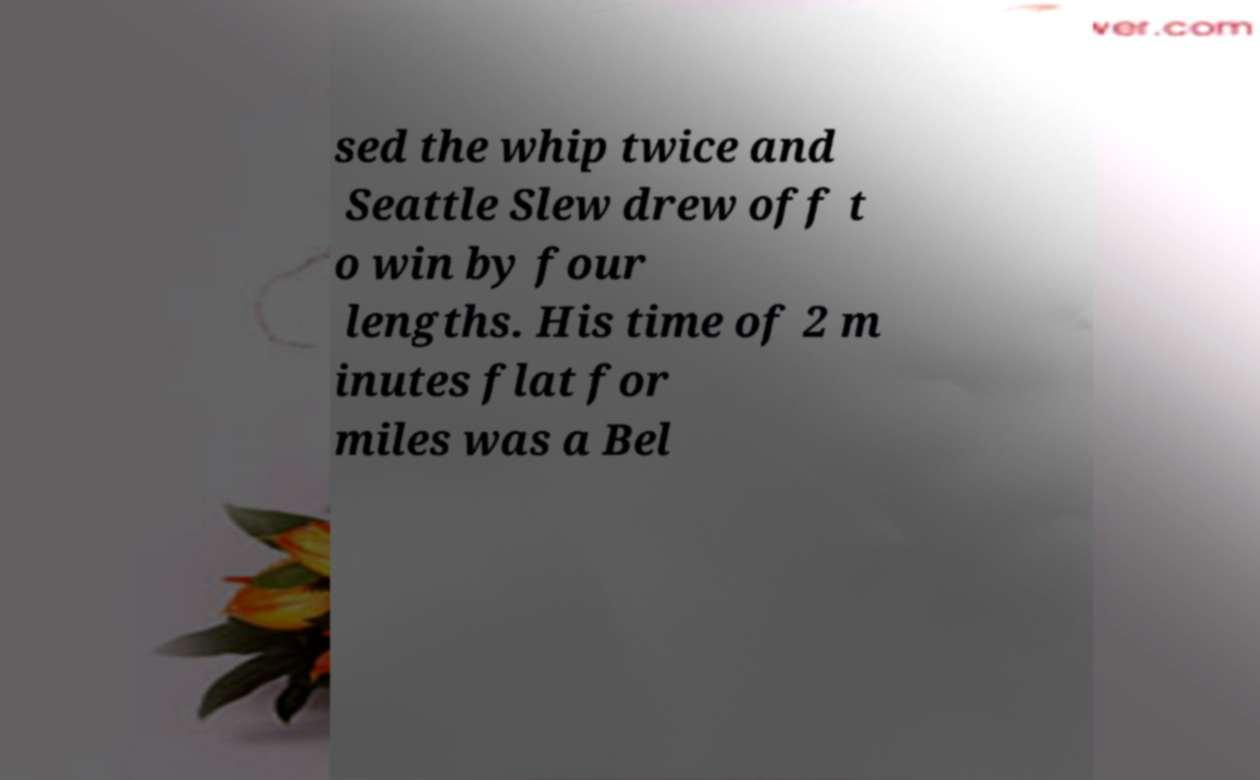I need the written content from this picture converted into text. Can you do that? sed the whip twice and Seattle Slew drew off t o win by four lengths. His time of 2 m inutes flat for miles was a Bel 